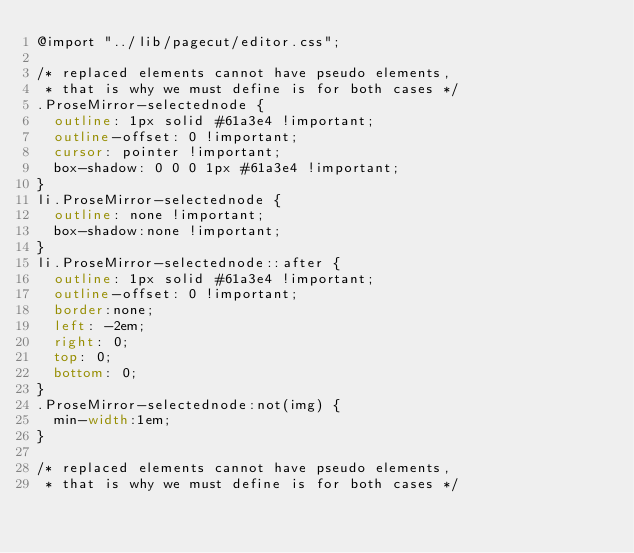Convert code to text. <code><loc_0><loc_0><loc_500><loc_500><_CSS_>@import "../lib/pagecut/editor.css";

/* replaced elements cannot have pseudo elements,
 * that is why we must define is for both cases */
.ProseMirror-selectednode {
	outline: 1px solid #61a3e4 !important;
	outline-offset: 0 !important;
	cursor: pointer !important;
	box-shadow: 0 0 0 1px #61a3e4 !important;
}
li.ProseMirror-selectednode {
	outline: none !important;
	box-shadow:none !important;
}
li.ProseMirror-selectednode::after {
	outline: 1px solid #61a3e4 !important;
	outline-offset: 0 !important;
	border:none;
	left: -2em;
	right: 0;
	top: 0;
	bottom: 0;
}
.ProseMirror-selectednode:not(img) {
	min-width:1em;
}

/* replaced elements cannot have pseudo elements,
 * that is why we must define is for both cases */</code> 